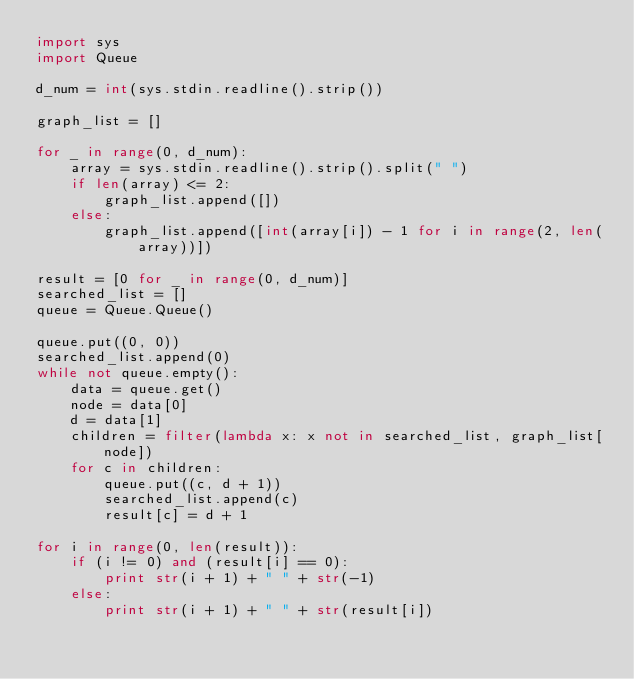<code> <loc_0><loc_0><loc_500><loc_500><_Python_>import sys
import Queue

d_num = int(sys.stdin.readline().strip())

graph_list = []

for _ in range(0, d_num):
    array = sys.stdin.readline().strip().split(" ")
    if len(array) <= 2:
        graph_list.append([])
    else:
        graph_list.append([int(array[i]) - 1 for i in range(2, len(array))])

result = [0 for _ in range(0, d_num)]
searched_list = []
queue = Queue.Queue()

queue.put((0, 0))
searched_list.append(0)
while not queue.empty():
    data = queue.get()
    node = data[0]
    d = data[1]
    children = filter(lambda x: x not in searched_list, graph_list[node])
    for c in children:
        queue.put((c, d + 1))
        searched_list.append(c)
        result[c] = d + 1

for i in range(0, len(result)):
    if (i != 0) and (result[i] == 0):
        print str(i + 1) + " " + str(-1)
    else:
        print str(i + 1) + " " + str(result[i])
            </code> 